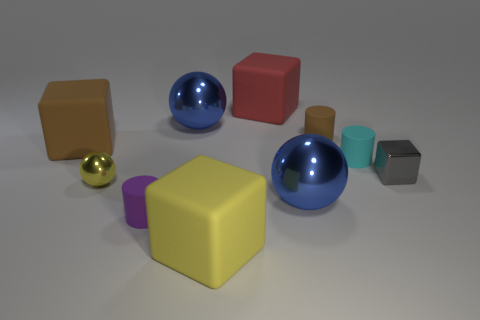Do the metal object that is behind the cyan rubber cylinder and the brown cylinder have the same size?
Ensure brevity in your answer.  No. How many metallic things are behind the big blue thing that is in front of the tiny ball?
Provide a short and direct response. 3. Are there any shiny objects that are left of the big rubber thing behind the brown object that is in front of the brown rubber cylinder?
Your response must be concise. Yes. There is a purple object that is the same shape as the tiny brown object; what material is it?
Your response must be concise. Rubber. Is the material of the gray cube the same as the big blue sphere behind the brown cylinder?
Offer a terse response. Yes. What is the shape of the brown thing that is left of the blue shiny sphere to the right of the large red rubber block?
Provide a succinct answer. Cube. How many large things are blue matte objects or blue balls?
Your response must be concise. 2. How many small gray rubber things are the same shape as the gray metal thing?
Offer a terse response. 0. There is a small cyan rubber object; does it have the same shape as the large blue object to the left of the large red thing?
Offer a terse response. No. How many rubber cylinders are in front of the tiny brown rubber thing?
Ensure brevity in your answer.  2. 